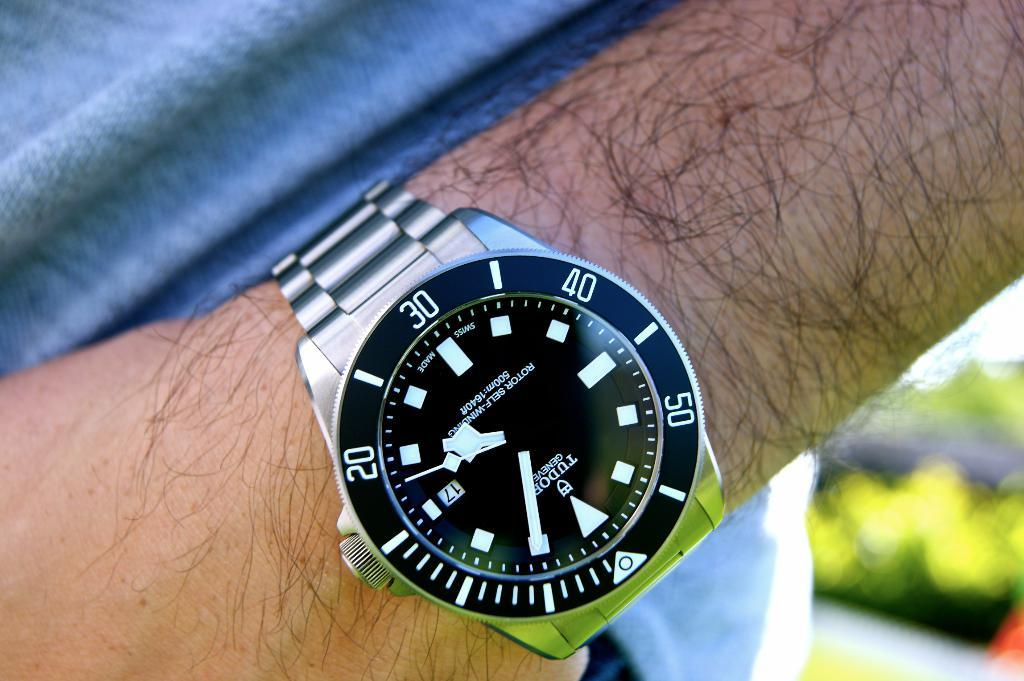<image>
Summarize the visual content of the image. the number 30 is at the top of a watch 